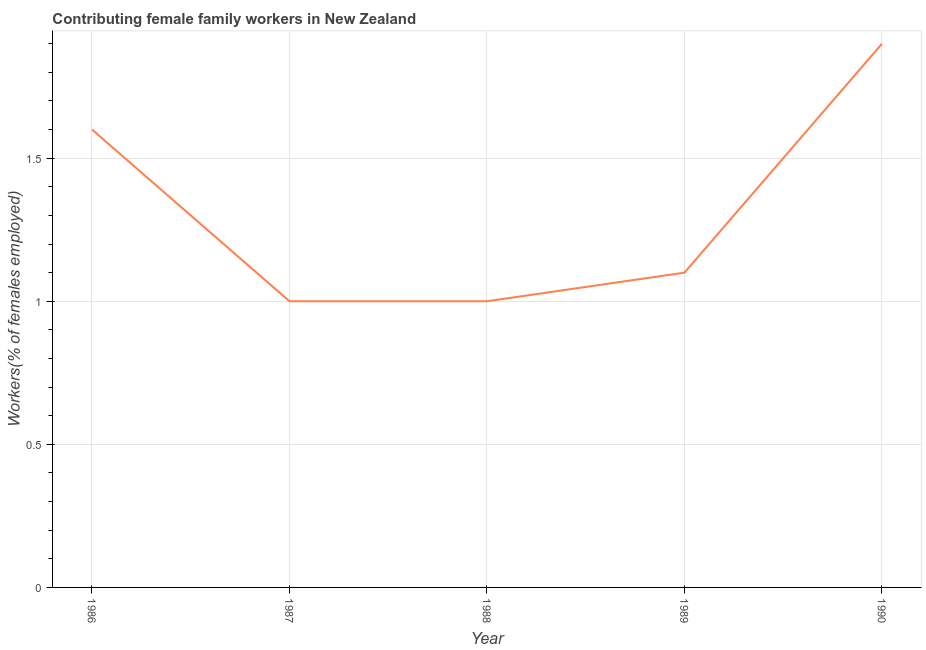What is the contributing female family workers in 1989?
Make the answer very short. 1.1. Across all years, what is the maximum contributing female family workers?
Ensure brevity in your answer.  1.9. In which year was the contributing female family workers maximum?
Give a very brief answer. 1990. What is the sum of the contributing female family workers?
Make the answer very short. 6.6. What is the difference between the contributing female family workers in 1987 and 1989?
Keep it short and to the point. -0.1. What is the average contributing female family workers per year?
Offer a terse response. 1.32. What is the median contributing female family workers?
Keep it short and to the point. 1.1. Do a majority of the years between 1990 and 1987 (inclusive) have contributing female family workers greater than 0.4 %?
Your response must be concise. Yes. What is the ratio of the contributing female family workers in 1989 to that in 1990?
Your answer should be very brief. 0.58. Is the contributing female family workers in 1987 less than that in 1988?
Your response must be concise. No. What is the difference between the highest and the second highest contributing female family workers?
Your response must be concise. 0.3. Is the sum of the contributing female family workers in 1987 and 1990 greater than the maximum contributing female family workers across all years?
Your response must be concise. Yes. What is the difference between the highest and the lowest contributing female family workers?
Provide a succinct answer. 0.9. In how many years, is the contributing female family workers greater than the average contributing female family workers taken over all years?
Your answer should be compact. 2. How many lines are there?
Keep it short and to the point. 1. What is the difference between two consecutive major ticks on the Y-axis?
Ensure brevity in your answer.  0.5. Are the values on the major ticks of Y-axis written in scientific E-notation?
Offer a very short reply. No. Does the graph contain any zero values?
Give a very brief answer. No. Does the graph contain grids?
Provide a short and direct response. Yes. What is the title of the graph?
Make the answer very short. Contributing female family workers in New Zealand. What is the label or title of the Y-axis?
Provide a short and direct response. Workers(% of females employed). What is the Workers(% of females employed) of 1986?
Provide a short and direct response. 1.6. What is the Workers(% of females employed) in 1987?
Offer a terse response. 1. What is the Workers(% of females employed) in 1988?
Give a very brief answer. 1. What is the Workers(% of females employed) of 1989?
Make the answer very short. 1.1. What is the Workers(% of females employed) in 1990?
Provide a succinct answer. 1.9. What is the difference between the Workers(% of females employed) in 1987 and 1988?
Ensure brevity in your answer.  0. What is the difference between the Workers(% of females employed) in 1987 and 1989?
Your answer should be very brief. -0.1. What is the difference between the Workers(% of females employed) in 1987 and 1990?
Keep it short and to the point. -0.9. What is the difference between the Workers(% of females employed) in 1988 and 1989?
Your answer should be compact. -0.1. What is the difference between the Workers(% of females employed) in 1988 and 1990?
Provide a short and direct response. -0.9. What is the ratio of the Workers(% of females employed) in 1986 to that in 1987?
Make the answer very short. 1.6. What is the ratio of the Workers(% of females employed) in 1986 to that in 1989?
Offer a very short reply. 1.46. What is the ratio of the Workers(% of females employed) in 1986 to that in 1990?
Ensure brevity in your answer.  0.84. What is the ratio of the Workers(% of females employed) in 1987 to that in 1989?
Make the answer very short. 0.91. What is the ratio of the Workers(% of females employed) in 1987 to that in 1990?
Offer a terse response. 0.53. What is the ratio of the Workers(% of females employed) in 1988 to that in 1989?
Your answer should be compact. 0.91. What is the ratio of the Workers(% of females employed) in 1988 to that in 1990?
Provide a succinct answer. 0.53. What is the ratio of the Workers(% of females employed) in 1989 to that in 1990?
Offer a terse response. 0.58. 